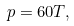<formula> <loc_0><loc_0><loc_500><loc_500>p = 6 0 T ,</formula> 